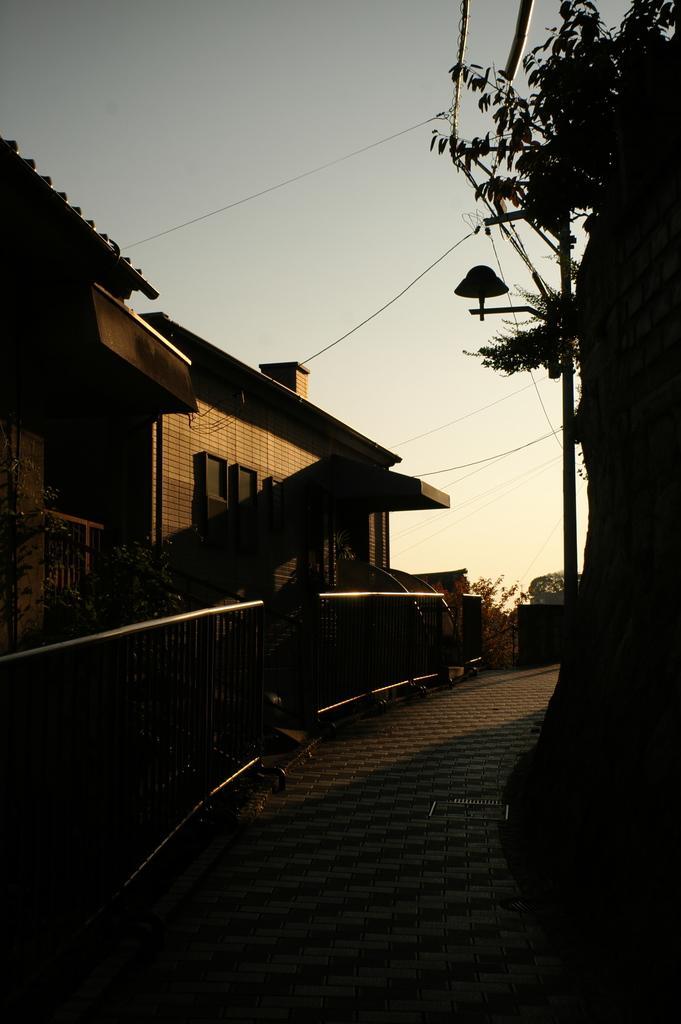Could you give a brief overview of what you see in this image? In this picture we can see the building and house. On the right there is an electric pole and wires are connected to it. Beside that we can see the plant. At the bottom there is a gate and fencing. At the top there is a sky. 